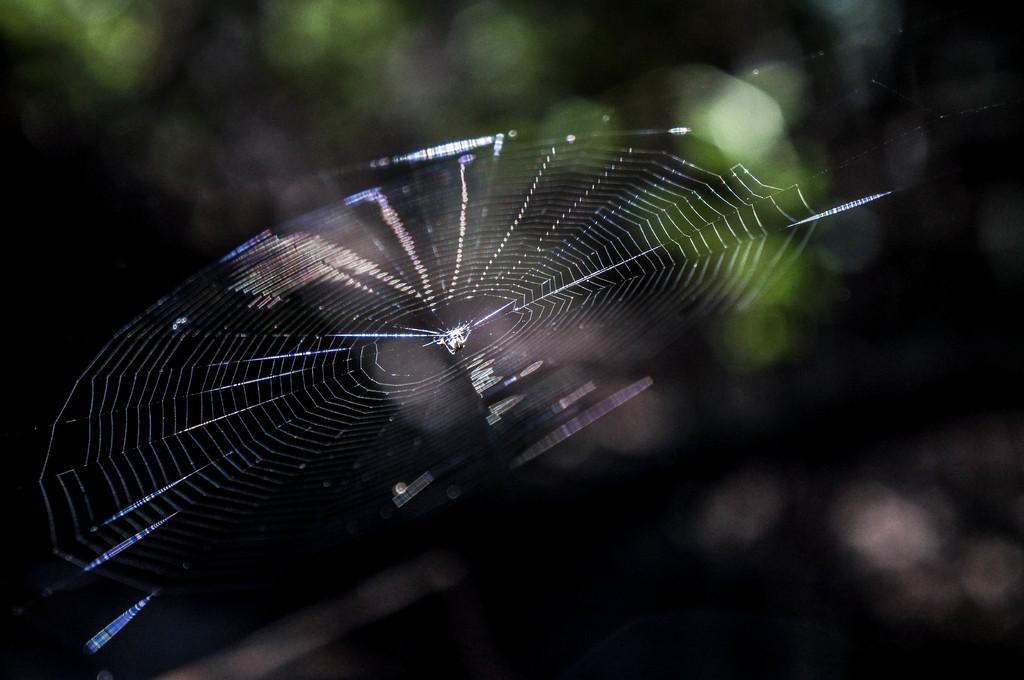What type of creature is in the image? There is an insect in the image. Where is the insect located? The insect is on a spider web. Can you describe the background of the image? The background of the image is blurred. What type of mint is growing near the insect in the image? There is no mint present in the image; it only features an insect on a spider web with a blurred background. 